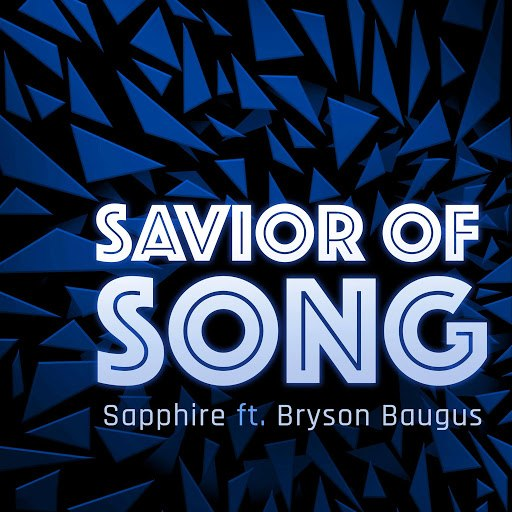What impact does the bold, white typography of 'SAVIOR OF SONG' have on the design? The bold, white typography used for 'SAVIOR OF SONG' stands in stark contrast to the chaotic, fragmented background of dark blues, making it immediately eye-catching and assertive. This typographic choice conveys a sense of clarity and authority, suggesting that the song carries a significant message or theme. It emphasizes the title as a central element of the artwork, potentially indicating the song's prominent position within its album or as a powerful single. 